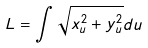<formula> <loc_0><loc_0><loc_500><loc_500>L = \int \sqrt { x _ { u } ^ { 2 } + y _ { u } ^ { 2 } } d u</formula> 